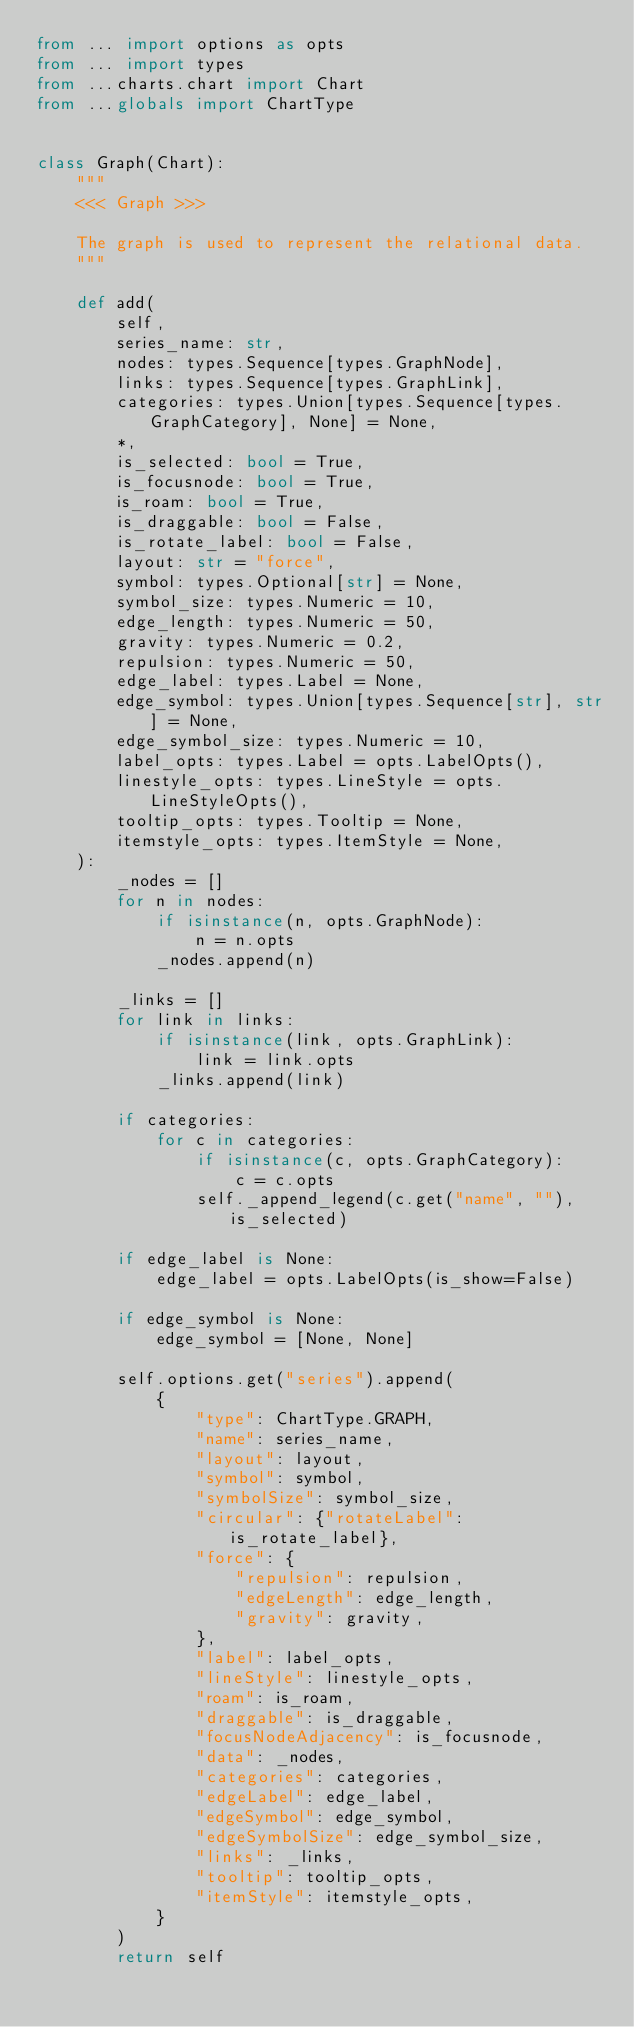Convert code to text. <code><loc_0><loc_0><loc_500><loc_500><_Python_>from ... import options as opts
from ... import types
from ...charts.chart import Chart
from ...globals import ChartType


class Graph(Chart):
    """
    <<< Graph >>>

    The graph is used to represent the relational data.
    """

    def add(
        self,
        series_name: str,
        nodes: types.Sequence[types.GraphNode],
        links: types.Sequence[types.GraphLink],
        categories: types.Union[types.Sequence[types.GraphCategory], None] = None,
        *,
        is_selected: bool = True,
        is_focusnode: bool = True,
        is_roam: bool = True,
        is_draggable: bool = False,
        is_rotate_label: bool = False,
        layout: str = "force",
        symbol: types.Optional[str] = None,
        symbol_size: types.Numeric = 10,
        edge_length: types.Numeric = 50,
        gravity: types.Numeric = 0.2,
        repulsion: types.Numeric = 50,
        edge_label: types.Label = None,
        edge_symbol: types.Union[types.Sequence[str], str] = None,
        edge_symbol_size: types.Numeric = 10,
        label_opts: types.Label = opts.LabelOpts(),
        linestyle_opts: types.LineStyle = opts.LineStyleOpts(),
        tooltip_opts: types.Tooltip = None,
        itemstyle_opts: types.ItemStyle = None,
    ):
        _nodes = []
        for n in nodes:
            if isinstance(n, opts.GraphNode):
                n = n.opts
            _nodes.append(n)

        _links = []
        for link in links:
            if isinstance(link, opts.GraphLink):
                link = link.opts
            _links.append(link)

        if categories:
            for c in categories:
                if isinstance(c, opts.GraphCategory):
                    c = c.opts
                self._append_legend(c.get("name", ""), is_selected)

        if edge_label is None:
            edge_label = opts.LabelOpts(is_show=False)

        if edge_symbol is None:
            edge_symbol = [None, None]

        self.options.get("series").append(
            {
                "type": ChartType.GRAPH,
                "name": series_name,
                "layout": layout,
                "symbol": symbol,
                "symbolSize": symbol_size,
                "circular": {"rotateLabel": is_rotate_label},
                "force": {
                    "repulsion": repulsion,
                    "edgeLength": edge_length,
                    "gravity": gravity,
                },
                "label": label_opts,
                "lineStyle": linestyle_opts,
                "roam": is_roam,
                "draggable": is_draggable,
                "focusNodeAdjacency": is_focusnode,
                "data": _nodes,
                "categories": categories,
                "edgeLabel": edge_label,
                "edgeSymbol": edge_symbol,
                "edgeSymbolSize": edge_symbol_size,
                "links": _links,
                "tooltip": tooltip_opts,
                "itemStyle": itemstyle_opts,
            }
        )
        return self
</code> 